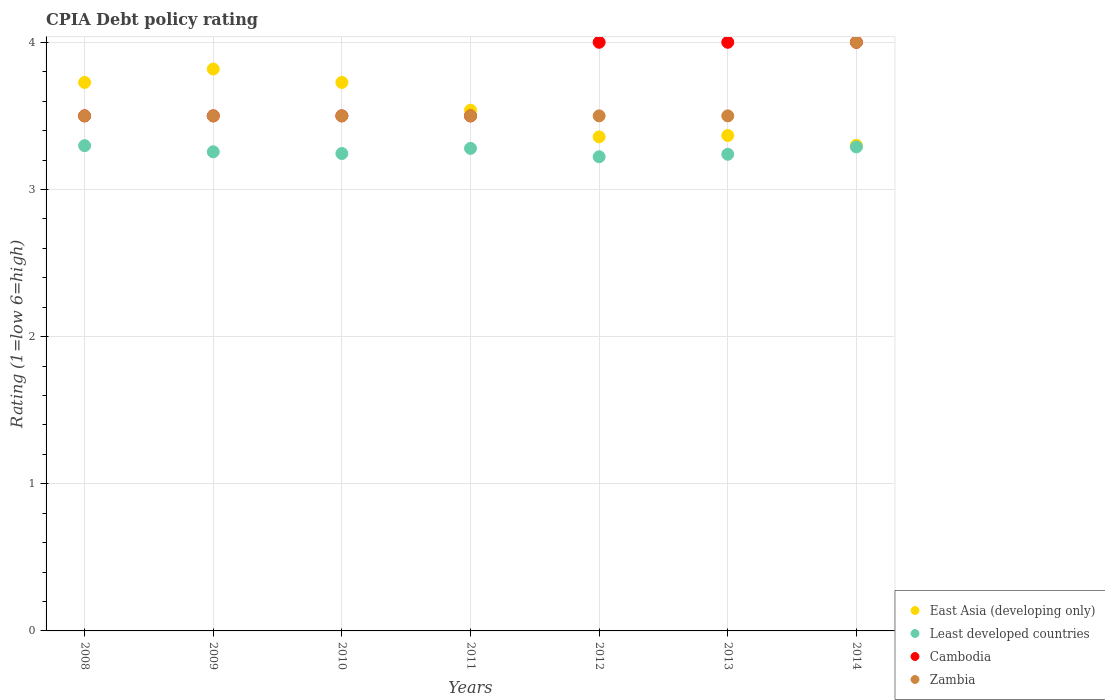Is the number of dotlines equal to the number of legend labels?
Ensure brevity in your answer.  Yes. What is the CPIA rating in Zambia in 2009?
Provide a short and direct response. 3.5. Across all years, what is the maximum CPIA rating in East Asia (developing only)?
Your answer should be very brief. 3.82. Across all years, what is the minimum CPIA rating in East Asia (developing only)?
Your response must be concise. 3.3. In which year was the CPIA rating in East Asia (developing only) maximum?
Your answer should be compact. 2009. In which year was the CPIA rating in East Asia (developing only) minimum?
Give a very brief answer. 2014. What is the total CPIA rating in East Asia (developing only) in the graph?
Your answer should be very brief. 24.83. What is the difference between the CPIA rating in East Asia (developing only) in 2012 and the CPIA rating in Cambodia in 2009?
Your response must be concise. -0.14. What is the average CPIA rating in East Asia (developing only) per year?
Your answer should be very brief. 3.55. In the year 2012, what is the difference between the CPIA rating in Least developed countries and CPIA rating in Cambodia?
Make the answer very short. -0.78. What is the ratio of the CPIA rating in Cambodia in 2008 to that in 2009?
Give a very brief answer. 1. Is the difference between the CPIA rating in Least developed countries in 2008 and 2013 greater than the difference between the CPIA rating in Cambodia in 2008 and 2013?
Keep it short and to the point. Yes. What is the difference between the highest and the second highest CPIA rating in Least developed countries?
Your answer should be compact. 0.01. In how many years, is the CPIA rating in Zambia greater than the average CPIA rating in Zambia taken over all years?
Keep it short and to the point. 1. Is the sum of the CPIA rating in East Asia (developing only) in 2009 and 2010 greater than the maximum CPIA rating in Cambodia across all years?
Your response must be concise. Yes. How many dotlines are there?
Make the answer very short. 4. Does the graph contain any zero values?
Provide a short and direct response. No. Does the graph contain grids?
Ensure brevity in your answer.  Yes. Where does the legend appear in the graph?
Your response must be concise. Bottom right. How are the legend labels stacked?
Provide a short and direct response. Vertical. What is the title of the graph?
Offer a terse response. CPIA Debt policy rating. Does "Kyrgyz Republic" appear as one of the legend labels in the graph?
Provide a short and direct response. No. What is the label or title of the Y-axis?
Keep it short and to the point. Rating (1=low 6=high). What is the Rating (1=low 6=high) of East Asia (developing only) in 2008?
Your response must be concise. 3.73. What is the Rating (1=low 6=high) of Least developed countries in 2008?
Provide a succinct answer. 3.3. What is the Rating (1=low 6=high) in East Asia (developing only) in 2009?
Offer a very short reply. 3.82. What is the Rating (1=low 6=high) of Least developed countries in 2009?
Your answer should be compact. 3.26. What is the Rating (1=low 6=high) in East Asia (developing only) in 2010?
Make the answer very short. 3.73. What is the Rating (1=low 6=high) in Least developed countries in 2010?
Your answer should be compact. 3.24. What is the Rating (1=low 6=high) in Cambodia in 2010?
Offer a terse response. 3.5. What is the Rating (1=low 6=high) of Zambia in 2010?
Your answer should be very brief. 3.5. What is the Rating (1=low 6=high) in East Asia (developing only) in 2011?
Offer a terse response. 3.54. What is the Rating (1=low 6=high) in Least developed countries in 2011?
Your response must be concise. 3.28. What is the Rating (1=low 6=high) of Cambodia in 2011?
Ensure brevity in your answer.  3.5. What is the Rating (1=low 6=high) of East Asia (developing only) in 2012?
Make the answer very short. 3.36. What is the Rating (1=low 6=high) in Least developed countries in 2012?
Ensure brevity in your answer.  3.22. What is the Rating (1=low 6=high) of East Asia (developing only) in 2013?
Offer a terse response. 3.37. What is the Rating (1=low 6=high) of Least developed countries in 2013?
Ensure brevity in your answer.  3.24. What is the Rating (1=low 6=high) of Least developed countries in 2014?
Keep it short and to the point. 3.29. What is the Rating (1=low 6=high) of Cambodia in 2014?
Offer a terse response. 4. What is the Rating (1=low 6=high) of Zambia in 2014?
Your answer should be compact. 4. Across all years, what is the maximum Rating (1=low 6=high) of East Asia (developing only)?
Offer a terse response. 3.82. Across all years, what is the maximum Rating (1=low 6=high) in Least developed countries?
Offer a terse response. 3.3. Across all years, what is the minimum Rating (1=low 6=high) in Least developed countries?
Your response must be concise. 3.22. Across all years, what is the minimum Rating (1=low 6=high) in Cambodia?
Your answer should be very brief. 3.5. Across all years, what is the minimum Rating (1=low 6=high) in Zambia?
Make the answer very short. 3.5. What is the total Rating (1=low 6=high) of East Asia (developing only) in the graph?
Keep it short and to the point. 24.84. What is the total Rating (1=low 6=high) in Least developed countries in the graph?
Ensure brevity in your answer.  22.83. What is the difference between the Rating (1=low 6=high) in East Asia (developing only) in 2008 and that in 2009?
Make the answer very short. -0.09. What is the difference between the Rating (1=low 6=high) of Least developed countries in 2008 and that in 2009?
Provide a short and direct response. 0.04. What is the difference between the Rating (1=low 6=high) in Cambodia in 2008 and that in 2009?
Make the answer very short. 0. What is the difference between the Rating (1=low 6=high) of Zambia in 2008 and that in 2009?
Ensure brevity in your answer.  0. What is the difference between the Rating (1=low 6=high) in Least developed countries in 2008 and that in 2010?
Offer a terse response. 0.05. What is the difference between the Rating (1=low 6=high) in Cambodia in 2008 and that in 2010?
Provide a short and direct response. 0. What is the difference between the Rating (1=low 6=high) in East Asia (developing only) in 2008 and that in 2011?
Your response must be concise. 0.19. What is the difference between the Rating (1=low 6=high) in Least developed countries in 2008 and that in 2011?
Offer a very short reply. 0.02. What is the difference between the Rating (1=low 6=high) of Cambodia in 2008 and that in 2011?
Keep it short and to the point. 0. What is the difference between the Rating (1=low 6=high) of Zambia in 2008 and that in 2011?
Offer a very short reply. 0. What is the difference between the Rating (1=low 6=high) of East Asia (developing only) in 2008 and that in 2012?
Keep it short and to the point. 0.37. What is the difference between the Rating (1=low 6=high) of Least developed countries in 2008 and that in 2012?
Ensure brevity in your answer.  0.08. What is the difference between the Rating (1=low 6=high) of East Asia (developing only) in 2008 and that in 2013?
Make the answer very short. 0.36. What is the difference between the Rating (1=low 6=high) in Least developed countries in 2008 and that in 2013?
Ensure brevity in your answer.  0.06. What is the difference between the Rating (1=low 6=high) of East Asia (developing only) in 2008 and that in 2014?
Give a very brief answer. 0.43. What is the difference between the Rating (1=low 6=high) of Least developed countries in 2008 and that in 2014?
Your response must be concise. 0.01. What is the difference between the Rating (1=low 6=high) of Cambodia in 2008 and that in 2014?
Offer a terse response. -0.5. What is the difference between the Rating (1=low 6=high) in East Asia (developing only) in 2009 and that in 2010?
Your answer should be compact. 0.09. What is the difference between the Rating (1=low 6=high) of Least developed countries in 2009 and that in 2010?
Your answer should be very brief. 0.01. What is the difference between the Rating (1=low 6=high) in Cambodia in 2009 and that in 2010?
Make the answer very short. 0. What is the difference between the Rating (1=low 6=high) in East Asia (developing only) in 2009 and that in 2011?
Ensure brevity in your answer.  0.28. What is the difference between the Rating (1=low 6=high) of Least developed countries in 2009 and that in 2011?
Ensure brevity in your answer.  -0.02. What is the difference between the Rating (1=low 6=high) in East Asia (developing only) in 2009 and that in 2012?
Give a very brief answer. 0.46. What is the difference between the Rating (1=low 6=high) of Least developed countries in 2009 and that in 2012?
Provide a succinct answer. 0.03. What is the difference between the Rating (1=low 6=high) in East Asia (developing only) in 2009 and that in 2013?
Provide a succinct answer. 0.45. What is the difference between the Rating (1=low 6=high) of Least developed countries in 2009 and that in 2013?
Make the answer very short. 0.02. What is the difference between the Rating (1=low 6=high) of Cambodia in 2009 and that in 2013?
Ensure brevity in your answer.  -0.5. What is the difference between the Rating (1=low 6=high) in Zambia in 2009 and that in 2013?
Give a very brief answer. 0. What is the difference between the Rating (1=low 6=high) of East Asia (developing only) in 2009 and that in 2014?
Your answer should be very brief. 0.52. What is the difference between the Rating (1=low 6=high) of Least developed countries in 2009 and that in 2014?
Provide a short and direct response. -0.03. What is the difference between the Rating (1=low 6=high) in Zambia in 2009 and that in 2014?
Provide a short and direct response. -0.5. What is the difference between the Rating (1=low 6=high) in East Asia (developing only) in 2010 and that in 2011?
Give a very brief answer. 0.19. What is the difference between the Rating (1=low 6=high) in Least developed countries in 2010 and that in 2011?
Your answer should be compact. -0.03. What is the difference between the Rating (1=low 6=high) in Cambodia in 2010 and that in 2011?
Give a very brief answer. 0. What is the difference between the Rating (1=low 6=high) in East Asia (developing only) in 2010 and that in 2012?
Keep it short and to the point. 0.37. What is the difference between the Rating (1=low 6=high) of Least developed countries in 2010 and that in 2012?
Offer a very short reply. 0.02. What is the difference between the Rating (1=low 6=high) of East Asia (developing only) in 2010 and that in 2013?
Your response must be concise. 0.36. What is the difference between the Rating (1=low 6=high) of Least developed countries in 2010 and that in 2013?
Offer a very short reply. 0.01. What is the difference between the Rating (1=low 6=high) in Cambodia in 2010 and that in 2013?
Provide a short and direct response. -0.5. What is the difference between the Rating (1=low 6=high) in Zambia in 2010 and that in 2013?
Ensure brevity in your answer.  0. What is the difference between the Rating (1=low 6=high) in East Asia (developing only) in 2010 and that in 2014?
Give a very brief answer. 0.43. What is the difference between the Rating (1=low 6=high) of Least developed countries in 2010 and that in 2014?
Your response must be concise. -0.04. What is the difference between the Rating (1=low 6=high) in Cambodia in 2010 and that in 2014?
Make the answer very short. -0.5. What is the difference between the Rating (1=low 6=high) of Zambia in 2010 and that in 2014?
Your answer should be very brief. -0.5. What is the difference between the Rating (1=low 6=high) in East Asia (developing only) in 2011 and that in 2012?
Keep it short and to the point. 0.18. What is the difference between the Rating (1=low 6=high) of Least developed countries in 2011 and that in 2012?
Your answer should be compact. 0.06. What is the difference between the Rating (1=low 6=high) of Cambodia in 2011 and that in 2012?
Your answer should be very brief. -0.5. What is the difference between the Rating (1=low 6=high) of Zambia in 2011 and that in 2012?
Provide a short and direct response. 0. What is the difference between the Rating (1=low 6=high) of East Asia (developing only) in 2011 and that in 2013?
Your answer should be very brief. 0.17. What is the difference between the Rating (1=low 6=high) of Least developed countries in 2011 and that in 2013?
Offer a very short reply. 0.04. What is the difference between the Rating (1=low 6=high) in Cambodia in 2011 and that in 2013?
Provide a succinct answer. -0.5. What is the difference between the Rating (1=low 6=high) of East Asia (developing only) in 2011 and that in 2014?
Your answer should be very brief. 0.24. What is the difference between the Rating (1=low 6=high) of Least developed countries in 2011 and that in 2014?
Give a very brief answer. -0.01. What is the difference between the Rating (1=low 6=high) in Cambodia in 2011 and that in 2014?
Provide a short and direct response. -0.5. What is the difference between the Rating (1=low 6=high) of Zambia in 2011 and that in 2014?
Your answer should be compact. -0.5. What is the difference between the Rating (1=low 6=high) in East Asia (developing only) in 2012 and that in 2013?
Ensure brevity in your answer.  -0.01. What is the difference between the Rating (1=low 6=high) of Least developed countries in 2012 and that in 2013?
Offer a very short reply. -0.02. What is the difference between the Rating (1=low 6=high) of Cambodia in 2012 and that in 2013?
Your answer should be very brief. 0. What is the difference between the Rating (1=low 6=high) in Zambia in 2012 and that in 2013?
Your answer should be very brief. 0. What is the difference between the Rating (1=low 6=high) of East Asia (developing only) in 2012 and that in 2014?
Your answer should be compact. 0.06. What is the difference between the Rating (1=low 6=high) of Least developed countries in 2012 and that in 2014?
Provide a short and direct response. -0.07. What is the difference between the Rating (1=low 6=high) of East Asia (developing only) in 2013 and that in 2014?
Give a very brief answer. 0.07. What is the difference between the Rating (1=low 6=high) of Least developed countries in 2013 and that in 2014?
Your answer should be very brief. -0.05. What is the difference between the Rating (1=low 6=high) of Cambodia in 2013 and that in 2014?
Offer a very short reply. 0. What is the difference between the Rating (1=low 6=high) in East Asia (developing only) in 2008 and the Rating (1=low 6=high) in Least developed countries in 2009?
Your answer should be very brief. 0.47. What is the difference between the Rating (1=low 6=high) in East Asia (developing only) in 2008 and the Rating (1=low 6=high) in Cambodia in 2009?
Ensure brevity in your answer.  0.23. What is the difference between the Rating (1=low 6=high) in East Asia (developing only) in 2008 and the Rating (1=low 6=high) in Zambia in 2009?
Provide a short and direct response. 0.23. What is the difference between the Rating (1=low 6=high) in Least developed countries in 2008 and the Rating (1=low 6=high) in Cambodia in 2009?
Your response must be concise. -0.2. What is the difference between the Rating (1=low 6=high) in Least developed countries in 2008 and the Rating (1=low 6=high) in Zambia in 2009?
Provide a succinct answer. -0.2. What is the difference between the Rating (1=low 6=high) of East Asia (developing only) in 2008 and the Rating (1=low 6=high) of Least developed countries in 2010?
Provide a short and direct response. 0.48. What is the difference between the Rating (1=low 6=high) of East Asia (developing only) in 2008 and the Rating (1=low 6=high) of Cambodia in 2010?
Make the answer very short. 0.23. What is the difference between the Rating (1=low 6=high) in East Asia (developing only) in 2008 and the Rating (1=low 6=high) in Zambia in 2010?
Your answer should be compact. 0.23. What is the difference between the Rating (1=low 6=high) of Least developed countries in 2008 and the Rating (1=low 6=high) of Cambodia in 2010?
Provide a succinct answer. -0.2. What is the difference between the Rating (1=low 6=high) in Least developed countries in 2008 and the Rating (1=low 6=high) in Zambia in 2010?
Your response must be concise. -0.2. What is the difference between the Rating (1=low 6=high) of Cambodia in 2008 and the Rating (1=low 6=high) of Zambia in 2010?
Your answer should be compact. 0. What is the difference between the Rating (1=low 6=high) in East Asia (developing only) in 2008 and the Rating (1=low 6=high) in Least developed countries in 2011?
Provide a short and direct response. 0.45. What is the difference between the Rating (1=low 6=high) in East Asia (developing only) in 2008 and the Rating (1=low 6=high) in Cambodia in 2011?
Your answer should be very brief. 0.23. What is the difference between the Rating (1=low 6=high) of East Asia (developing only) in 2008 and the Rating (1=low 6=high) of Zambia in 2011?
Provide a succinct answer. 0.23. What is the difference between the Rating (1=low 6=high) of Least developed countries in 2008 and the Rating (1=low 6=high) of Cambodia in 2011?
Provide a succinct answer. -0.2. What is the difference between the Rating (1=low 6=high) in Least developed countries in 2008 and the Rating (1=low 6=high) in Zambia in 2011?
Provide a succinct answer. -0.2. What is the difference between the Rating (1=low 6=high) of East Asia (developing only) in 2008 and the Rating (1=low 6=high) of Least developed countries in 2012?
Provide a succinct answer. 0.51. What is the difference between the Rating (1=low 6=high) in East Asia (developing only) in 2008 and the Rating (1=low 6=high) in Cambodia in 2012?
Offer a terse response. -0.27. What is the difference between the Rating (1=low 6=high) of East Asia (developing only) in 2008 and the Rating (1=low 6=high) of Zambia in 2012?
Provide a short and direct response. 0.23. What is the difference between the Rating (1=low 6=high) in Least developed countries in 2008 and the Rating (1=low 6=high) in Cambodia in 2012?
Provide a short and direct response. -0.7. What is the difference between the Rating (1=low 6=high) in Least developed countries in 2008 and the Rating (1=low 6=high) in Zambia in 2012?
Your answer should be very brief. -0.2. What is the difference between the Rating (1=low 6=high) in Cambodia in 2008 and the Rating (1=low 6=high) in Zambia in 2012?
Ensure brevity in your answer.  0. What is the difference between the Rating (1=low 6=high) in East Asia (developing only) in 2008 and the Rating (1=low 6=high) in Least developed countries in 2013?
Offer a terse response. 0.49. What is the difference between the Rating (1=low 6=high) in East Asia (developing only) in 2008 and the Rating (1=low 6=high) in Cambodia in 2013?
Make the answer very short. -0.27. What is the difference between the Rating (1=low 6=high) in East Asia (developing only) in 2008 and the Rating (1=low 6=high) in Zambia in 2013?
Your answer should be very brief. 0.23. What is the difference between the Rating (1=low 6=high) of Least developed countries in 2008 and the Rating (1=low 6=high) of Cambodia in 2013?
Your answer should be compact. -0.7. What is the difference between the Rating (1=low 6=high) of Least developed countries in 2008 and the Rating (1=low 6=high) of Zambia in 2013?
Provide a succinct answer. -0.2. What is the difference between the Rating (1=low 6=high) of Cambodia in 2008 and the Rating (1=low 6=high) of Zambia in 2013?
Offer a very short reply. 0. What is the difference between the Rating (1=low 6=high) in East Asia (developing only) in 2008 and the Rating (1=low 6=high) in Least developed countries in 2014?
Offer a terse response. 0.44. What is the difference between the Rating (1=low 6=high) in East Asia (developing only) in 2008 and the Rating (1=low 6=high) in Cambodia in 2014?
Your answer should be very brief. -0.27. What is the difference between the Rating (1=low 6=high) in East Asia (developing only) in 2008 and the Rating (1=low 6=high) in Zambia in 2014?
Make the answer very short. -0.27. What is the difference between the Rating (1=low 6=high) in Least developed countries in 2008 and the Rating (1=low 6=high) in Cambodia in 2014?
Ensure brevity in your answer.  -0.7. What is the difference between the Rating (1=low 6=high) in Least developed countries in 2008 and the Rating (1=low 6=high) in Zambia in 2014?
Ensure brevity in your answer.  -0.7. What is the difference between the Rating (1=low 6=high) in East Asia (developing only) in 2009 and the Rating (1=low 6=high) in Least developed countries in 2010?
Your response must be concise. 0.57. What is the difference between the Rating (1=low 6=high) in East Asia (developing only) in 2009 and the Rating (1=low 6=high) in Cambodia in 2010?
Your answer should be compact. 0.32. What is the difference between the Rating (1=low 6=high) in East Asia (developing only) in 2009 and the Rating (1=low 6=high) in Zambia in 2010?
Your response must be concise. 0.32. What is the difference between the Rating (1=low 6=high) of Least developed countries in 2009 and the Rating (1=low 6=high) of Cambodia in 2010?
Provide a succinct answer. -0.24. What is the difference between the Rating (1=low 6=high) in Least developed countries in 2009 and the Rating (1=low 6=high) in Zambia in 2010?
Your answer should be compact. -0.24. What is the difference between the Rating (1=low 6=high) in East Asia (developing only) in 2009 and the Rating (1=low 6=high) in Least developed countries in 2011?
Your answer should be very brief. 0.54. What is the difference between the Rating (1=low 6=high) of East Asia (developing only) in 2009 and the Rating (1=low 6=high) of Cambodia in 2011?
Keep it short and to the point. 0.32. What is the difference between the Rating (1=low 6=high) of East Asia (developing only) in 2009 and the Rating (1=low 6=high) of Zambia in 2011?
Your answer should be very brief. 0.32. What is the difference between the Rating (1=low 6=high) in Least developed countries in 2009 and the Rating (1=low 6=high) in Cambodia in 2011?
Make the answer very short. -0.24. What is the difference between the Rating (1=low 6=high) in Least developed countries in 2009 and the Rating (1=low 6=high) in Zambia in 2011?
Give a very brief answer. -0.24. What is the difference between the Rating (1=low 6=high) in East Asia (developing only) in 2009 and the Rating (1=low 6=high) in Least developed countries in 2012?
Offer a terse response. 0.6. What is the difference between the Rating (1=low 6=high) of East Asia (developing only) in 2009 and the Rating (1=low 6=high) of Cambodia in 2012?
Keep it short and to the point. -0.18. What is the difference between the Rating (1=low 6=high) in East Asia (developing only) in 2009 and the Rating (1=low 6=high) in Zambia in 2012?
Provide a short and direct response. 0.32. What is the difference between the Rating (1=low 6=high) in Least developed countries in 2009 and the Rating (1=low 6=high) in Cambodia in 2012?
Your answer should be very brief. -0.74. What is the difference between the Rating (1=low 6=high) in Least developed countries in 2009 and the Rating (1=low 6=high) in Zambia in 2012?
Provide a short and direct response. -0.24. What is the difference between the Rating (1=low 6=high) of East Asia (developing only) in 2009 and the Rating (1=low 6=high) of Least developed countries in 2013?
Ensure brevity in your answer.  0.58. What is the difference between the Rating (1=low 6=high) of East Asia (developing only) in 2009 and the Rating (1=low 6=high) of Cambodia in 2013?
Your answer should be compact. -0.18. What is the difference between the Rating (1=low 6=high) of East Asia (developing only) in 2009 and the Rating (1=low 6=high) of Zambia in 2013?
Give a very brief answer. 0.32. What is the difference between the Rating (1=low 6=high) in Least developed countries in 2009 and the Rating (1=low 6=high) in Cambodia in 2013?
Your response must be concise. -0.74. What is the difference between the Rating (1=low 6=high) in Least developed countries in 2009 and the Rating (1=low 6=high) in Zambia in 2013?
Offer a very short reply. -0.24. What is the difference between the Rating (1=low 6=high) of East Asia (developing only) in 2009 and the Rating (1=low 6=high) of Least developed countries in 2014?
Provide a short and direct response. 0.53. What is the difference between the Rating (1=low 6=high) in East Asia (developing only) in 2009 and the Rating (1=low 6=high) in Cambodia in 2014?
Your response must be concise. -0.18. What is the difference between the Rating (1=low 6=high) of East Asia (developing only) in 2009 and the Rating (1=low 6=high) of Zambia in 2014?
Offer a very short reply. -0.18. What is the difference between the Rating (1=low 6=high) in Least developed countries in 2009 and the Rating (1=low 6=high) in Cambodia in 2014?
Your response must be concise. -0.74. What is the difference between the Rating (1=low 6=high) in Least developed countries in 2009 and the Rating (1=low 6=high) in Zambia in 2014?
Offer a very short reply. -0.74. What is the difference between the Rating (1=low 6=high) in East Asia (developing only) in 2010 and the Rating (1=low 6=high) in Least developed countries in 2011?
Make the answer very short. 0.45. What is the difference between the Rating (1=low 6=high) of East Asia (developing only) in 2010 and the Rating (1=low 6=high) of Cambodia in 2011?
Offer a terse response. 0.23. What is the difference between the Rating (1=low 6=high) in East Asia (developing only) in 2010 and the Rating (1=low 6=high) in Zambia in 2011?
Give a very brief answer. 0.23. What is the difference between the Rating (1=low 6=high) in Least developed countries in 2010 and the Rating (1=low 6=high) in Cambodia in 2011?
Offer a terse response. -0.26. What is the difference between the Rating (1=low 6=high) of Least developed countries in 2010 and the Rating (1=low 6=high) of Zambia in 2011?
Provide a succinct answer. -0.26. What is the difference between the Rating (1=low 6=high) of East Asia (developing only) in 2010 and the Rating (1=low 6=high) of Least developed countries in 2012?
Your answer should be compact. 0.51. What is the difference between the Rating (1=low 6=high) of East Asia (developing only) in 2010 and the Rating (1=low 6=high) of Cambodia in 2012?
Offer a very short reply. -0.27. What is the difference between the Rating (1=low 6=high) of East Asia (developing only) in 2010 and the Rating (1=low 6=high) of Zambia in 2012?
Provide a succinct answer. 0.23. What is the difference between the Rating (1=low 6=high) of Least developed countries in 2010 and the Rating (1=low 6=high) of Cambodia in 2012?
Provide a succinct answer. -0.76. What is the difference between the Rating (1=low 6=high) of Least developed countries in 2010 and the Rating (1=low 6=high) of Zambia in 2012?
Provide a succinct answer. -0.26. What is the difference between the Rating (1=low 6=high) of East Asia (developing only) in 2010 and the Rating (1=low 6=high) of Least developed countries in 2013?
Provide a succinct answer. 0.49. What is the difference between the Rating (1=low 6=high) in East Asia (developing only) in 2010 and the Rating (1=low 6=high) in Cambodia in 2013?
Ensure brevity in your answer.  -0.27. What is the difference between the Rating (1=low 6=high) of East Asia (developing only) in 2010 and the Rating (1=low 6=high) of Zambia in 2013?
Your answer should be compact. 0.23. What is the difference between the Rating (1=low 6=high) of Least developed countries in 2010 and the Rating (1=low 6=high) of Cambodia in 2013?
Give a very brief answer. -0.76. What is the difference between the Rating (1=low 6=high) of Least developed countries in 2010 and the Rating (1=low 6=high) of Zambia in 2013?
Give a very brief answer. -0.26. What is the difference between the Rating (1=low 6=high) in East Asia (developing only) in 2010 and the Rating (1=low 6=high) in Least developed countries in 2014?
Your response must be concise. 0.44. What is the difference between the Rating (1=low 6=high) of East Asia (developing only) in 2010 and the Rating (1=low 6=high) of Cambodia in 2014?
Keep it short and to the point. -0.27. What is the difference between the Rating (1=low 6=high) of East Asia (developing only) in 2010 and the Rating (1=low 6=high) of Zambia in 2014?
Keep it short and to the point. -0.27. What is the difference between the Rating (1=low 6=high) of Least developed countries in 2010 and the Rating (1=low 6=high) of Cambodia in 2014?
Your answer should be very brief. -0.76. What is the difference between the Rating (1=low 6=high) of Least developed countries in 2010 and the Rating (1=low 6=high) of Zambia in 2014?
Offer a very short reply. -0.76. What is the difference between the Rating (1=low 6=high) of Cambodia in 2010 and the Rating (1=low 6=high) of Zambia in 2014?
Provide a short and direct response. -0.5. What is the difference between the Rating (1=low 6=high) of East Asia (developing only) in 2011 and the Rating (1=low 6=high) of Least developed countries in 2012?
Your answer should be very brief. 0.32. What is the difference between the Rating (1=low 6=high) of East Asia (developing only) in 2011 and the Rating (1=low 6=high) of Cambodia in 2012?
Your answer should be compact. -0.46. What is the difference between the Rating (1=low 6=high) in East Asia (developing only) in 2011 and the Rating (1=low 6=high) in Zambia in 2012?
Your response must be concise. 0.04. What is the difference between the Rating (1=low 6=high) in Least developed countries in 2011 and the Rating (1=low 6=high) in Cambodia in 2012?
Give a very brief answer. -0.72. What is the difference between the Rating (1=low 6=high) in Least developed countries in 2011 and the Rating (1=low 6=high) in Zambia in 2012?
Make the answer very short. -0.22. What is the difference between the Rating (1=low 6=high) of Cambodia in 2011 and the Rating (1=low 6=high) of Zambia in 2012?
Your answer should be very brief. 0. What is the difference between the Rating (1=low 6=high) of East Asia (developing only) in 2011 and the Rating (1=low 6=high) of Least developed countries in 2013?
Ensure brevity in your answer.  0.3. What is the difference between the Rating (1=low 6=high) of East Asia (developing only) in 2011 and the Rating (1=low 6=high) of Cambodia in 2013?
Provide a short and direct response. -0.46. What is the difference between the Rating (1=low 6=high) of East Asia (developing only) in 2011 and the Rating (1=low 6=high) of Zambia in 2013?
Keep it short and to the point. 0.04. What is the difference between the Rating (1=low 6=high) in Least developed countries in 2011 and the Rating (1=low 6=high) in Cambodia in 2013?
Your answer should be compact. -0.72. What is the difference between the Rating (1=low 6=high) of Least developed countries in 2011 and the Rating (1=low 6=high) of Zambia in 2013?
Offer a terse response. -0.22. What is the difference between the Rating (1=low 6=high) in Cambodia in 2011 and the Rating (1=low 6=high) in Zambia in 2013?
Offer a terse response. 0. What is the difference between the Rating (1=low 6=high) in East Asia (developing only) in 2011 and the Rating (1=low 6=high) in Least developed countries in 2014?
Ensure brevity in your answer.  0.25. What is the difference between the Rating (1=low 6=high) of East Asia (developing only) in 2011 and the Rating (1=low 6=high) of Cambodia in 2014?
Provide a short and direct response. -0.46. What is the difference between the Rating (1=low 6=high) of East Asia (developing only) in 2011 and the Rating (1=low 6=high) of Zambia in 2014?
Provide a short and direct response. -0.46. What is the difference between the Rating (1=low 6=high) in Least developed countries in 2011 and the Rating (1=low 6=high) in Cambodia in 2014?
Keep it short and to the point. -0.72. What is the difference between the Rating (1=low 6=high) in Least developed countries in 2011 and the Rating (1=low 6=high) in Zambia in 2014?
Give a very brief answer. -0.72. What is the difference between the Rating (1=low 6=high) in East Asia (developing only) in 2012 and the Rating (1=low 6=high) in Least developed countries in 2013?
Provide a succinct answer. 0.12. What is the difference between the Rating (1=low 6=high) in East Asia (developing only) in 2012 and the Rating (1=low 6=high) in Cambodia in 2013?
Offer a very short reply. -0.64. What is the difference between the Rating (1=low 6=high) in East Asia (developing only) in 2012 and the Rating (1=low 6=high) in Zambia in 2013?
Make the answer very short. -0.14. What is the difference between the Rating (1=low 6=high) in Least developed countries in 2012 and the Rating (1=low 6=high) in Cambodia in 2013?
Keep it short and to the point. -0.78. What is the difference between the Rating (1=low 6=high) of Least developed countries in 2012 and the Rating (1=low 6=high) of Zambia in 2013?
Your answer should be very brief. -0.28. What is the difference between the Rating (1=low 6=high) of Cambodia in 2012 and the Rating (1=low 6=high) of Zambia in 2013?
Make the answer very short. 0.5. What is the difference between the Rating (1=low 6=high) in East Asia (developing only) in 2012 and the Rating (1=low 6=high) in Least developed countries in 2014?
Your answer should be compact. 0.07. What is the difference between the Rating (1=low 6=high) of East Asia (developing only) in 2012 and the Rating (1=low 6=high) of Cambodia in 2014?
Your answer should be very brief. -0.64. What is the difference between the Rating (1=low 6=high) of East Asia (developing only) in 2012 and the Rating (1=low 6=high) of Zambia in 2014?
Ensure brevity in your answer.  -0.64. What is the difference between the Rating (1=low 6=high) in Least developed countries in 2012 and the Rating (1=low 6=high) in Cambodia in 2014?
Your response must be concise. -0.78. What is the difference between the Rating (1=low 6=high) of Least developed countries in 2012 and the Rating (1=low 6=high) of Zambia in 2014?
Your response must be concise. -0.78. What is the difference between the Rating (1=low 6=high) in East Asia (developing only) in 2013 and the Rating (1=low 6=high) in Least developed countries in 2014?
Your response must be concise. 0.08. What is the difference between the Rating (1=low 6=high) in East Asia (developing only) in 2013 and the Rating (1=low 6=high) in Cambodia in 2014?
Ensure brevity in your answer.  -0.63. What is the difference between the Rating (1=low 6=high) in East Asia (developing only) in 2013 and the Rating (1=low 6=high) in Zambia in 2014?
Offer a very short reply. -0.63. What is the difference between the Rating (1=low 6=high) of Least developed countries in 2013 and the Rating (1=low 6=high) of Cambodia in 2014?
Provide a short and direct response. -0.76. What is the difference between the Rating (1=low 6=high) in Least developed countries in 2013 and the Rating (1=low 6=high) in Zambia in 2014?
Provide a succinct answer. -0.76. What is the average Rating (1=low 6=high) in East Asia (developing only) per year?
Give a very brief answer. 3.55. What is the average Rating (1=low 6=high) of Least developed countries per year?
Offer a terse response. 3.26. What is the average Rating (1=low 6=high) of Cambodia per year?
Provide a succinct answer. 3.71. What is the average Rating (1=low 6=high) of Zambia per year?
Offer a very short reply. 3.57. In the year 2008, what is the difference between the Rating (1=low 6=high) in East Asia (developing only) and Rating (1=low 6=high) in Least developed countries?
Your answer should be compact. 0.43. In the year 2008, what is the difference between the Rating (1=low 6=high) in East Asia (developing only) and Rating (1=low 6=high) in Cambodia?
Make the answer very short. 0.23. In the year 2008, what is the difference between the Rating (1=low 6=high) in East Asia (developing only) and Rating (1=low 6=high) in Zambia?
Your response must be concise. 0.23. In the year 2008, what is the difference between the Rating (1=low 6=high) in Least developed countries and Rating (1=low 6=high) in Cambodia?
Ensure brevity in your answer.  -0.2. In the year 2008, what is the difference between the Rating (1=low 6=high) in Least developed countries and Rating (1=low 6=high) in Zambia?
Your answer should be compact. -0.2. In the year 2009, what is the difference between the Rating (1=low 6=high) in East Asia (developing only) and Rating (1=low 6=high) in Least developed countries?
Your answer should be very brief. 0.56. In the year 2009, what is the difference between the Rating (1=low 6=high) in East Asia (developing only) and Rating (1=low 6=high) in Cambodia?
Give a very brief answer. 0.32. In the year 2009, what is the difference between the Rating (1=low 6=high) of East Asia (developing only) and Rating (1=low 6=high) of Zambia?
Your response must be concise. 0.32. In the year 2009, what is the difference between the Rating (1=low 6=high) of Least developed countries and Rating (1=low 6=high) of Cambodia?
Give a very brief answer. -0.24. In the year 2009, what is the difference between the Rating (1=low 6=high) in Least developed countries and Rating (1=low 6=high) in Zambia?
Ensure brevity in your answer.  -0.24. In the year 2009, what is the difference between the Rating (1=low 6=high) in Cambodia and Rating (1=low 6=high) in Zambia?
Give a very brief answer. 0. In the year 2010, what is the difference between the Rating (1=low 6=high) in East Asia (developing only) and Rating (1=low 6=high) in Least developed countries?
Give a very brief answer. 0.48. In the year 2010, what is the difference between the Rating (1=low 6=high) of East Asia (developing only) and Rating (1=low 6=high) of Cambodia?
Your answer should be very brief. 0.23. In the year 2010, what is the difference between the Rating (1=low 6=high) of East Asia (developing only) and Rating (1=low 6=high) of Zambia?
Provide a succinct answer. 0.23. In the year 2010, what is the difference between the Rating (1=low 6=high) of Least developed countries and Rating (1=low 6=high) of Cambodia?
Offer a very short reply. -0.26. In the year 2010, what is the difference between the Rating (1=low 6=high) of Least developed countries and Rating (1=low 6=high) of Zambia?
Your answer should be compact. -0.26. In the year 2010, what is the difference between the Rating (1=low 6=high) of Cambodia and Rating (1=low 6=high) of Zambia?
Offer a terse response. 0. In the year 2011, what is the difference between the Rating (1=low 6=high) in East Asia (developing only) and Rating (1=low 6=high) in Least developed countries?
Your response must be concise. 0.26. In the year 2011, what is the difference between the Rating (1=low 6=high) of East Asia (developing only) and Rating (1=low 6=high) of Cambodia?
Make the answer very short. 0.04. In the year 2011, what is the difference between the Rating (1=low 6=high) in East Asia (developing only) and Rating (1=low 6=high) in Zambia?
Offer a very short reply. 0.04. In the year 2011, what is the difference between the Rating (1=low 6=high) in Least developed countries and Rating (1=low 6=high) in Cambodia?
Make the answer very short. -0.22. In the year 2011, what is the difference between the Rating (1=low 6=high) in Least developed countries and Rating (1=low 6=high) in Zambia?
Your answer should be very brief. -0.22. In the year 2011, what is the difference between the Rating (1=low 6=high) of Cambodia and Rating (1=low 6=high) of Zambia?
Give a very brief answer. 0. In the year 2012, what is the difference between the Rating (1=low 6=high) of East Asia (developing only) and Rating (1=low 6=high) of Least developed countries?
Offer a terse response. 0.13. In the year 2012, what is the difference between the Rating (1=low 6=high) in East Asia (developing only) and Rating (1=low 6=high) in Cambodia?
Ensure brevity in your answer.  -0.64. In the year 2012, what is the difference between the Rating (1=low 6=high) in East Asia (developing only) and Rating (1=low 6=high) in Zambia?
Keep it short and to the point. -0.14. In the year 2012, what is the difference between the Rating (1=low 6=high) in Least developed countries and Rating (1=low 6=high) in Cambodia?
Your answer should be compact. -0.78. In the year 2012, what is the difference between the Rating (1=low 6=high) of Least developed countries and Rating (1=low 6=high) of Zambia?
Give a very brief answer. -0.28. In the year 2013, what is the difference between the Rating (1=low 6=high) in East Asia (developing only) and Rating (1=low 6=high) in Least developed countries?
Your answer should be compact. 0.13. In the year 2013, what is the difference between the Rating (1=low 6=high) of East Asia (developing only) and Rating (1=low 6=high) of Cambodia?
Offer a very short reply. -0.63. In the year 2013, what is the difference between the Rating (1=low 6=high) in East Asia (developing only) and Rating (1=low 6=high) in Zambia?
Provide a succinct answer. -0.13. In the year 2013, what is the difference between the Rating (1=low 6=high) in Least developed countries and Rating (1=low 6=high) in Cambodia?
Give a very brief answer. -0.76. In the year 2013, what is the difference between the Rating (1=low 6=high) in Least developed countries and Rating (1=low 6=high) in Zambia?
Offer a very short reply. -0.26. In the year 2013, what is the difference between the Rating (1=low 6=high) of Cambodia and Rating (1=low 6=high) of Zambia?
Your answer should be compact. 0.5. In the year 2014, what is the difference between the Rating (1=low 6=high) in East Asia (developing only) and Rating (1=low 6=high) in Least developed countries?
Offer a terse response. 0.01. In the year 2014, what is the difference between the Rating (1=low 6=high) of East Asia (developing only) and Rating (1=low 6=high) of Cambodia?
Your response must be concise. -0.7. In the year 2014, what is the difference between the Rating (1=low 6=high) of Least developed countries and Rating (1=low 6=high) of Cambodia?
Provide a short and direct response. -0.71. In the year 2014, what is the difference between the Rating (1=low 6=high) of Least developed countries and Rating (1=low 6=high) of Zambia?
Provide a short and direct response. -0.71. In the year 2014, what is the difference between the Rating (1=low 6=high) in Cambodia and Rating (1=low 6=high) in Zambia?
Provide a short and direct response. 0. What is the ratio of the Rating (1=low 6=high) of East Asia (developing only) in 2008 to that in 2009?
Your answer should be compact. 0.98. What is the ratio of the Rating (1=low 6=high) in Least developed countries in 2008 to that in 2009?
Your answer should be very brief. 1.01. What is the ratio of the Rating (1=low 6=high) of Cambodia in 2008 to that in 2009?
Your answer should be very brief. 1. What is the ratio of the Rating (1=low 6=high) of East Asia (developing only) in 2008 to that in 2010?
Your response must be concise. 1. What is the ratio of the Rating (1=low 6=high) of Least developed countries in 2008 to that in 2010?
Offer a very short reply. 1.02. What is the ratio of the Rating (1=low 6=high) in Cambodia in 2008 to that in 2010?
Your response must be concise. 1. What is the ratio of the Rating (1=low 6=high) of Zambia in 2008 to that in 2010?
Your response must be concise. 1. What is the ratio of the Rating (1=low 6=high) of East Asia (developing only) in 2008 to that in 2011?
Keep it short and to the point. 1.05. What is the ratio of the Rating (1=low 6=high) of Least developed countries in 2008 to that in 2011?
Your answer should be very brief. 1.01. What is the ratio of the Rating (1=low 6=high) in Cambodia in 2008 to that in 2011?
Ensure brevity in your answer.  1. What is the ratio of the Rating (1=low 6=high) of Zambia in 2008 to that in 2011?
Your answer should be compact. 1. What is the ratio of the Rating (1=low 6=high) of East Asia (developing only) in 2008 to that in 2012?
Offer a very short reply. 1.11. What is the ratio of the Rating (1=low 6=high) in Least developed countries in 2008 to that in 2012?
Provide a short and direct response. 1.02. What is the ratio of the Rating (1=low 6=high) in Cambodia in 2008 to that in 2012?
Ensure brevity in your answer.  0.88. What is the ratio of the Rating (1=low 6=high) in Zambia in 2008 to that in 2012?
Offer a terse response. 1. What is the ratio of the Rating (1=low 6=high) of East Asia (developing only) in 2008 to that in 2013?
Provide a short and direct response. 1.11. What is the ratio of the Rating (1=low 6=high) in Least developed countries in 2008 to that in 2013?
Make the answer very short. 1.02. What is the ratio of the Rating (1=low 6=high) in East Asia (developing only) in 2008 to that in 2014?
Your response must be concise. 1.13. What is the ratio of the Rating (1=low 6=high) of Zambia in 2008 to that in 2014?
Give a very brief answer. 0.88. What is the ratio of the Rating (1=low 6=high) of East Asia (developing only) in 2009 to that in 2010?
Your answer should be very brief. 1.02. What is the ratio of the Rating (1=low 6=high) of Least developed countries in 2009 to that in 2010?
Make the answer very short. 1. What is the ratio of the Rating (1=low 6=high) of Cambodia in 2009 to that in 2010?
Offer a very short reply. 1. What is the ratio of the Rating (1=low 6=high) in East Asia (developing only) in 2009 to that in 2011?
Your answer should be compact. 1.08. What is the ratio of the Rating (1=low 6=high) of Least developed countries in 2009 to that in 2011?
Provide a succinct answer. 0.99. What is the ratio of the Rating (1=low 6=high) of Zambia in 2009 to that in 2011?
Your answer should be compact. 1. What is the ratio of the Rating (1=low 6=high) of East Asia (developing only) in 2009 to that in 2012?
Make the answer very short. 1.14. What is the ratio of the Rating (1=low 6=high) in Least developed countries in 2009 to that in 2012?
Make the answer very short. 1.01. What is the ratio of the Rating (1=low 6=high) in East Asia (developing only) in 2009 to that in 2013?
Make the answer very short. 1.13. What is the ratio of the Rating (1=low 6=high) of Zambia in 2009 to that in 2013?
Offer a very short reply. 1. What is the ratio of the Rating (1=low 6=high) of East Asia (developing only) in 2009 to that in 2014?
Give a very brief answer. 1.16. What is the ratio of the Rating (1=low 6=high) of Least developed countries in 2009 to that in 2014?
Ensure brevity in your answer.  0.99. What is the ratio of the Rating (1=low 6=high) of Zambia in 2009 to that in 2014?
Provide a short and direct response. 0.88. What is the ratio of the Rating (1=low 6=high) in East Asia (developing only) in 2010 to that in 2011?
Provide a short and direct response. 1.05. What is the ratio of the Rating (1=low 6=high) of Least developed countries in 2010 to that in 2011?
Give a very brief answer. 0.99. What is the ratio of the Rating (1=low 6=high) of Zambia in 2010 to that in 2011?
Your response must be concise. 1. What is the ratio of the Rating (1=low 6=high) of East Asia (developing only) in 2010 to that in 2012?
Keep it short and to the point. 1.11. What is the ratio of the Rating (1=low 6=high) in Least developed countries in 2010 to that in 2012?
Keep it short and to the point. 1.01. What is the ratio of the Rating (1=low 6=high) of Zambia in 2010 to that in 2012?
Offer a terse response. 1. What is the ratio of the Rating (1=low 6=high) of East Asia (developing only) in 2010 to that in 2013?
Your answer should be very brief. 1.11. What is the ratio of the Rating (1=low 6=high) of Least developed countries in 2010 to that in 2013?
Your answer should be compact. 1. What is the ratio of the Rating (1=low 6=high) in East Asia (developing only) in 2010 to that in 2014?
Your answer should be compact. 1.13. What is the ratio of the Rating (1=low 6=high) in Least developed countries in 2010 to that in 2014?
Keep it short and to the point. 0.99. What is the ratio of the Rating (1=low 6=high) in Cambodia in 2010 to that in 2014?
Ensure brevity in your answer.  0.88. What is the ratio of the Rating (1=low 6=high) in Zambia in 2010 to that in 2014?
Offer a very short reply. 0.88. What is the ratio of the Rating (1=low 6=high) in East Asia (developing only) in 2011 to that in 2012?
Your answer should be compact. 1.05. What is the ratio of the Rating (1=low 6=high) in Least developed countries in 2011 to that in 2012?
Your answer should be compact. 1.02. What is the ratio of the Rating (1=low 6=high) of Cambodia in 2011 to that in 2012?
Give a very brief answer. 0.88. What is the ratio of the Rating (1=low 6=high) in Zambia in 2011 to that in 2012?
Offer a very short reply. 1. What is the ratio of the Rating (1=low 6=high) of East Asia (developing only) in 2011 to that in 2013?
Make the answer very short. 1.05. What is the ratio of the Rating (1=low 6=high) in Least developed countries in 2011 to that in 2013?
Your response must be concise. 1.01. What is the ratio of the Rating (1=low 6=high) of Cambodia in 2011 to that in 2013?
Your answer should be very brief. 0.88. What is the ratio of the Rating (1=low 6=high) of East Asia (developing only) in 2011 to that in 2014?
Your answer should be compact. 1.07. What is the ratio of the Rating (1=low 6=high) of Cambodia in 2012 to that in 2013?
Your response must be concise. 1. What is the ratio of the Rating (1=low 6=high) of East Asia (developing only) in 2012 to that in 2014?
Your answer should be very brief. 1.02. What is the ratio of the Rating (1=low 6=high) in Least developed countries in 2012 to that in 2014?
Keep it short and to the point. 0.98. What is the ratio of the Rating (1=low 6=high) in Cambodia in 2012 to that in 2014?
Your answer should be compact. 1. What is the ratio of the Rating (1=low 6=high) of East Asia (developing only) in 2013 to that in 2014?
Your answer should be very brief. 1.02. What is the ratio of the Rating (1=low 6=high) of Least developed countries in 2013 to that in 2014?
Offer a terse response. 0.98. What is the ratio of the Rating (1=low 6=high) of Cambodia in 2013 to that in 2014?
Keep it short and to the point. 1. What is the difference between the highest and the second highest Rating (1=low 6=high) in East Asia (developing only)?
Your answer should be very brief. 0.09. What is the difference between the highest and the second highest Rating (1=low 6=high) of Least developed countries?
Ensure brevity in your answer.  0.01. What is the difference between the highest and the lowest Rating (1=low 6=high) of East Asia (developing only)?
Provide a succinct answer. 0.52. What is the difference between the highest and the lowest Rating (1=low 6=high) of Least developed countries?
Your answer should be compact. 0.08. What is the difference between the highest and the lowest Rating (1=low 6=high) in Cambodia?
Your response must be concise. 0.5. 